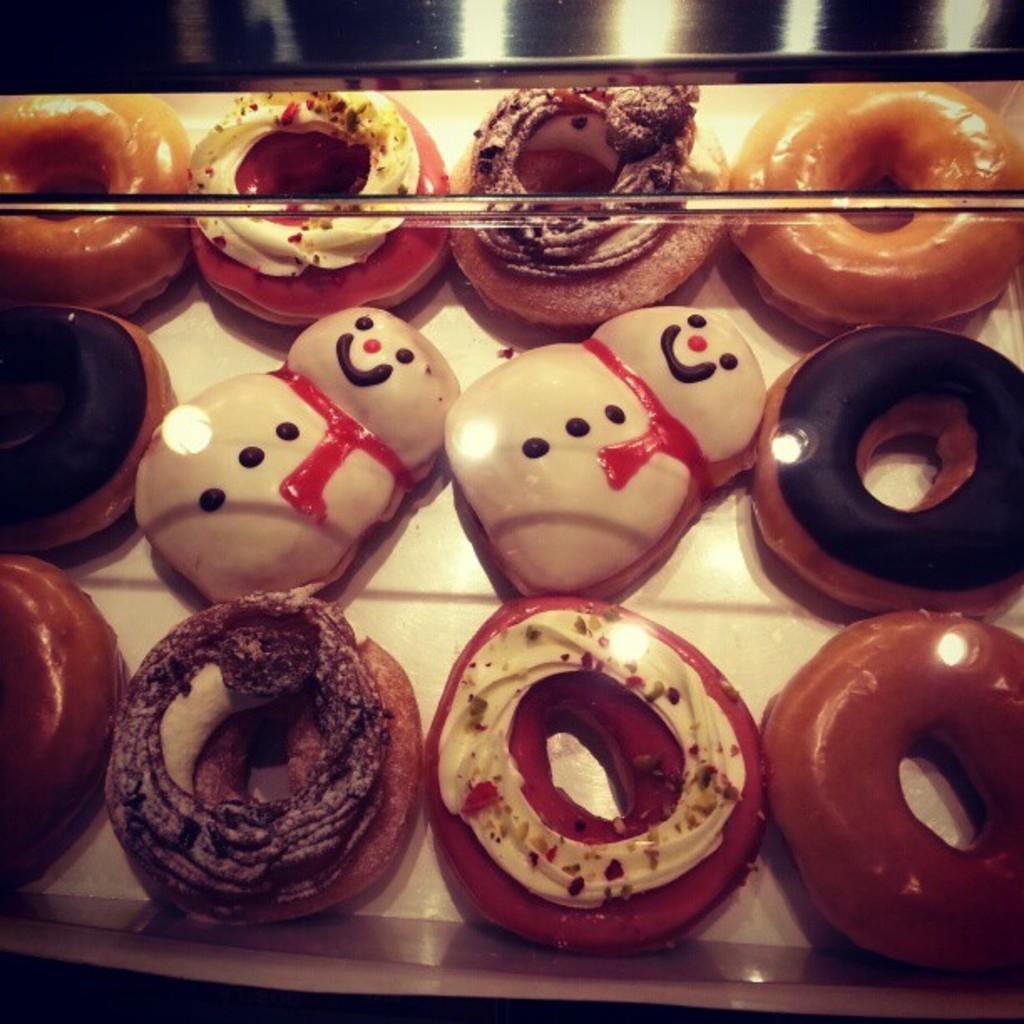What type of food is shown in the image? There are different varieties of doughnuts in the image. How are the doughnuts arranged in the image? The doughnuts are placed in a tray. What type of property can be seen in the background of the image? There is no property visible in the image; it only shows doughnuts in a tray. 